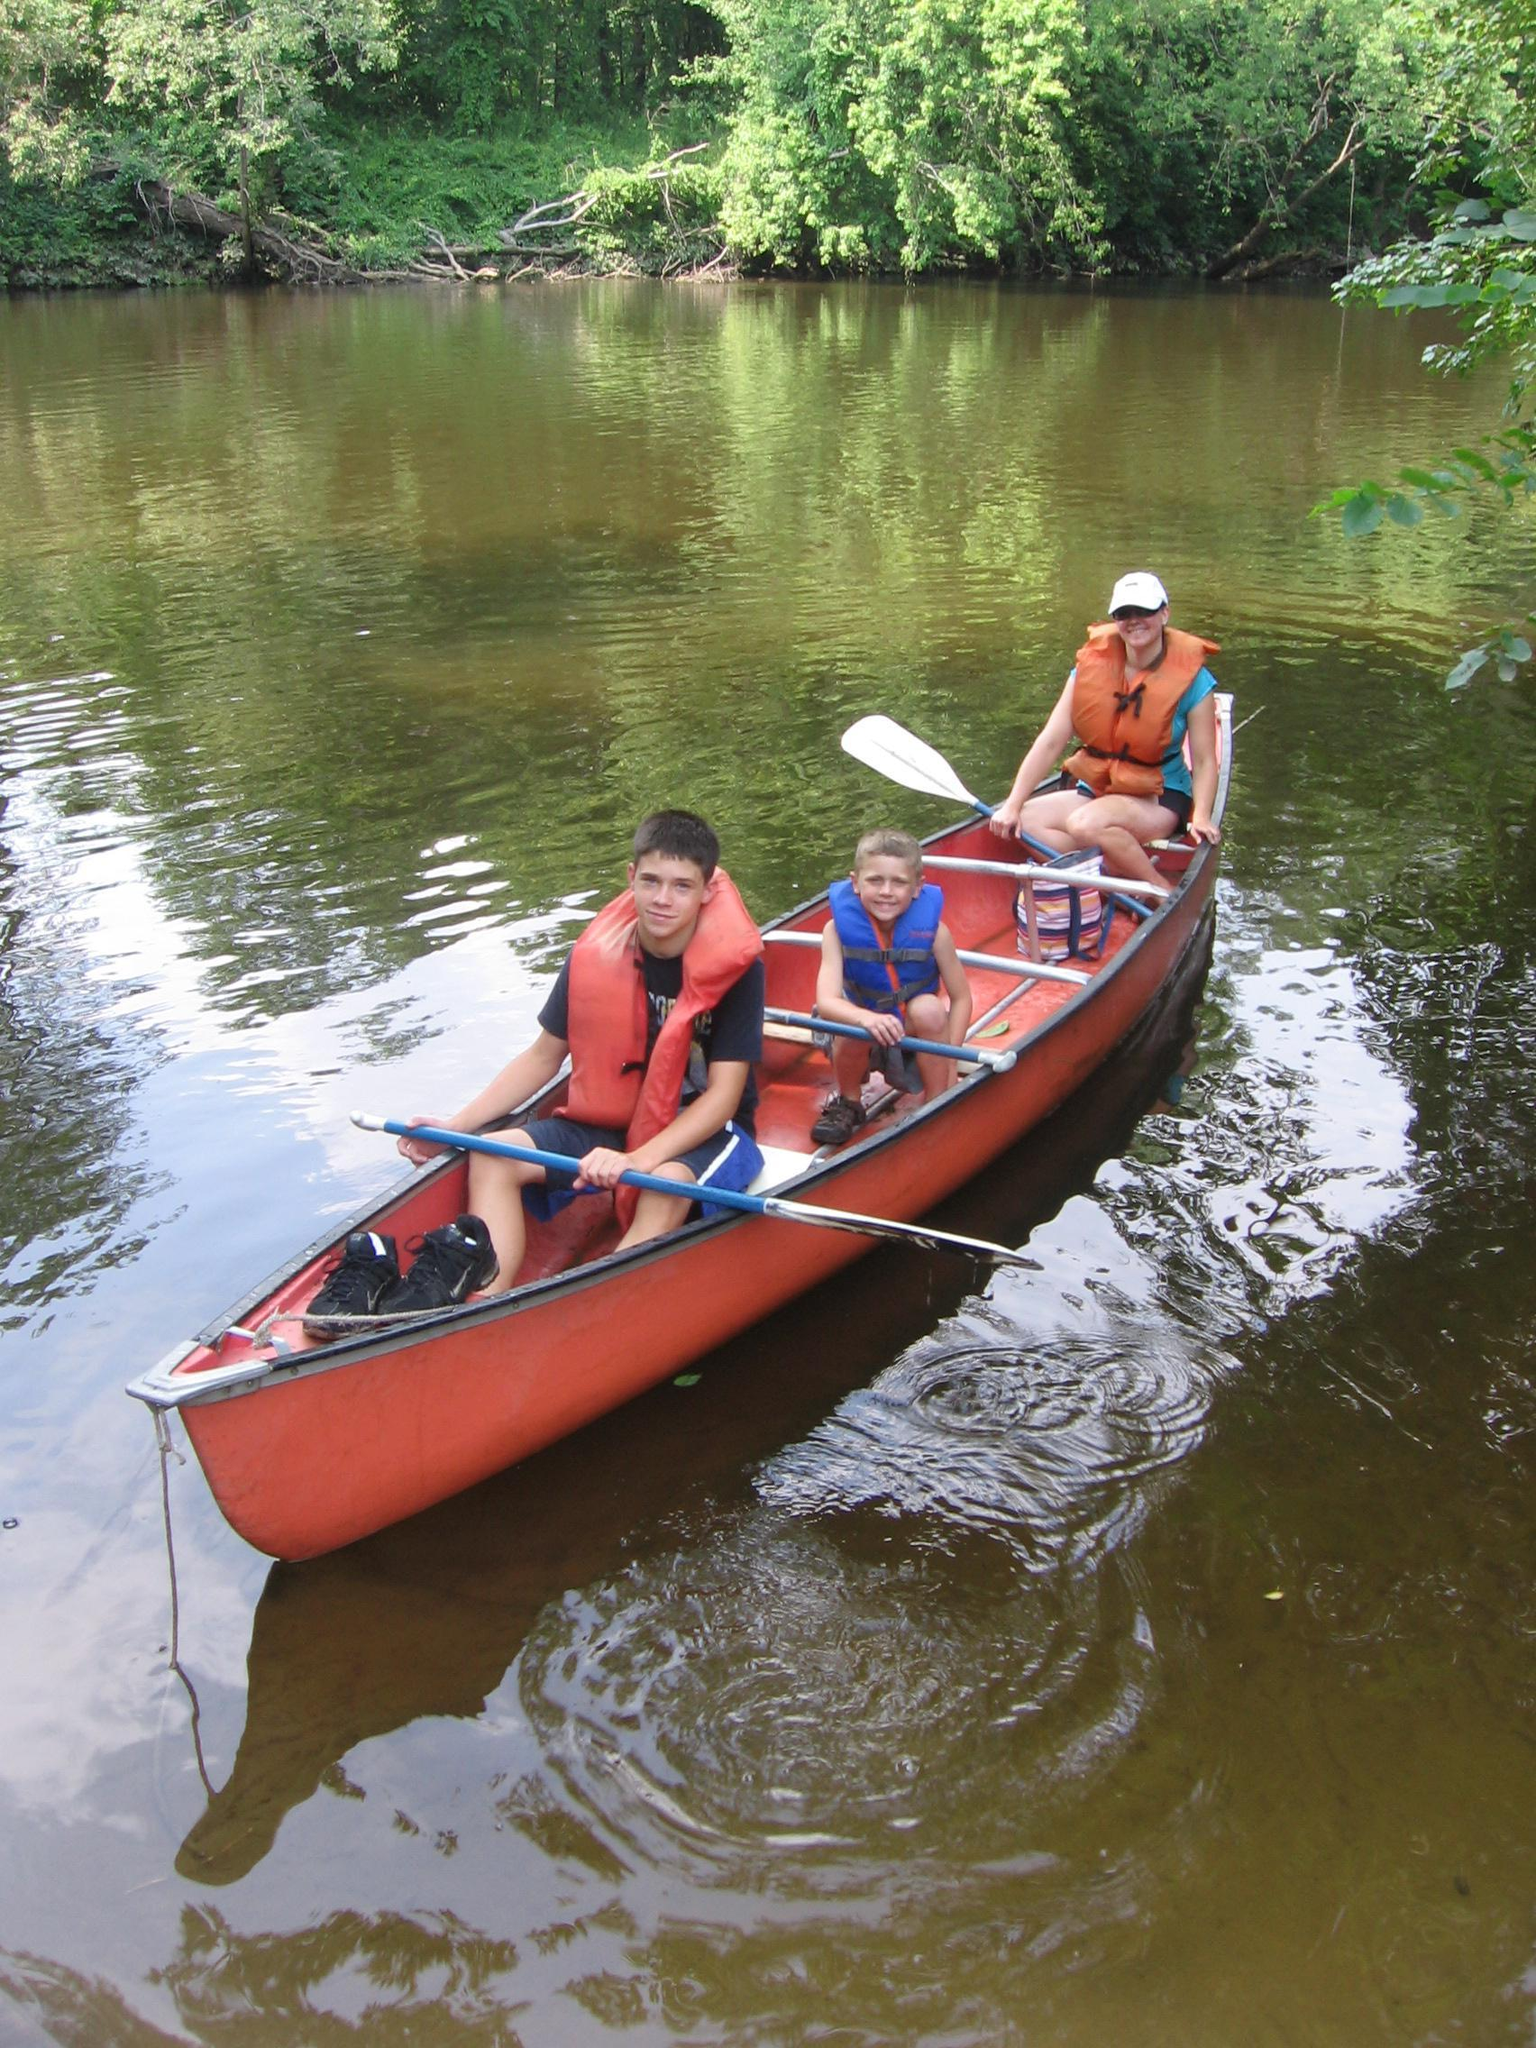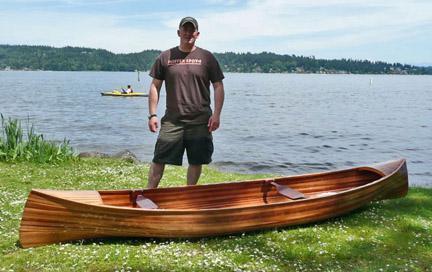The first image is the image on the left, the second image is the image on the right. Examine the images to the left and right. Is the description "An image includes a canoe with multiple riders afloat on the water." accurate? Answer yes or no. Yes. The first image is the image on the left, the second image is the image on the right. Analyze the images presented: Is the assertion "At least one person is standing on the shore in the image on the right." valid? Answer yes or no. Yes. 